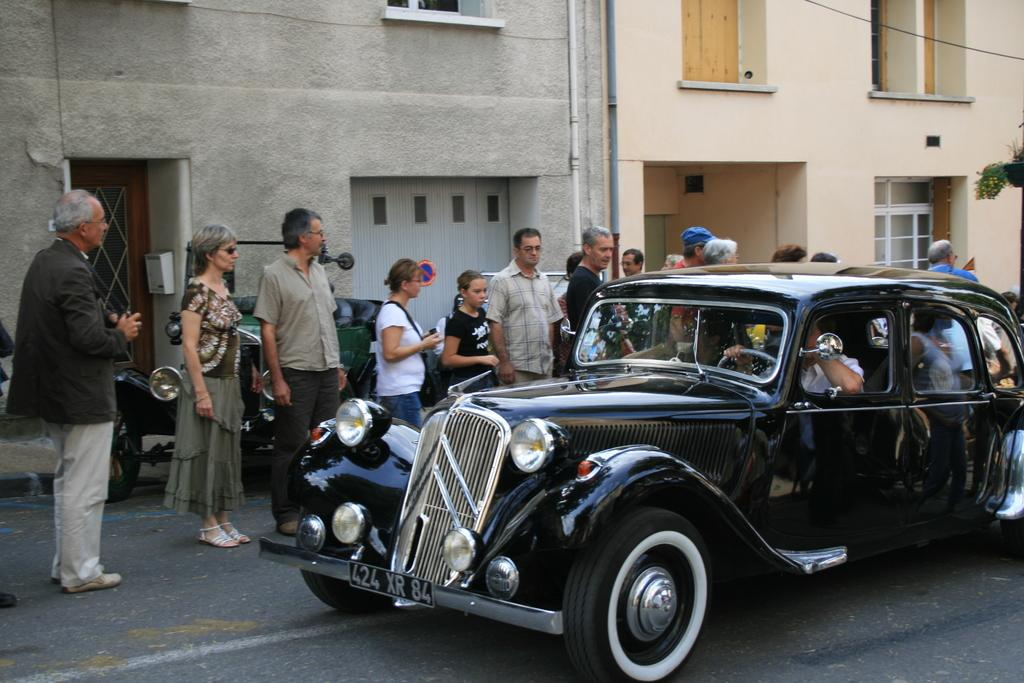What is on the road in the image? There is a car on the road in the image. What can be seen on the left side of the road? There are people standing on the left side of the road. What is visible in the background of the image? There are buildings in the background. How many potatoes are being carried by the car in the image? There are no potatoes visible in the image; the car is the main subject on the road. 